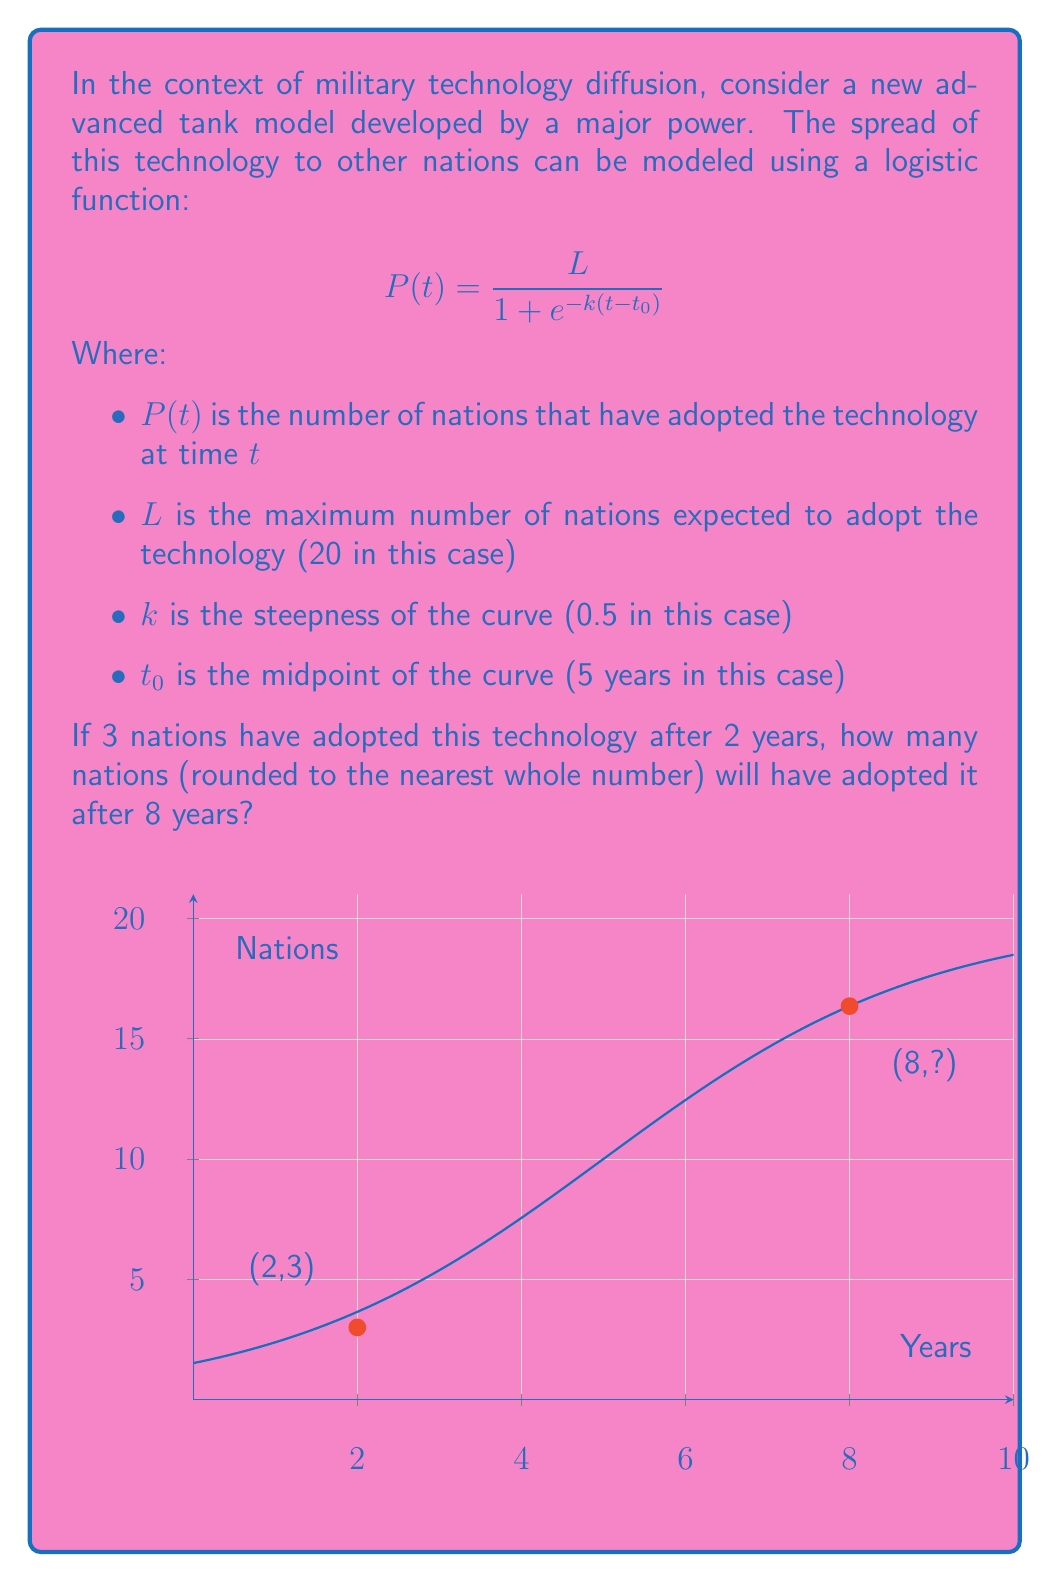Give your solution to this math problem. Let's approach this step-by-step:

1) We're given the logistic function: 
   $$P(t) = \frac{L}{1 + e^{-k(t-t_0)}}$$

2) We know:
   $L = 20$, $k = 0.5$, $t_0 = 5$

3) We need to find $P(8)$. Let's substitute these values:
   $$P(8) = \frac{20}{1 + e^{-0.5(8-5)}}$$

4) Simplify inside the exponential:
   $$P(8) = \frac{20}{1 + e^{-0.5(3)}}$$

5) Calculate:
   $$P(8) = \frac{20}{1 + e^{-1.5}}$$

6) $e^{-1.5} \approx 0.2231$

7) Substitute:
   $$P(8) = \frac{20}{1 + 0.2231} \approx 16.3511$$

8) Rounding to the nearest whole number:
   $P(8) \approx 16$

Therefore, after 8 years, approximately 16 nations will have adopted the technology.
Answer: 16 nations 